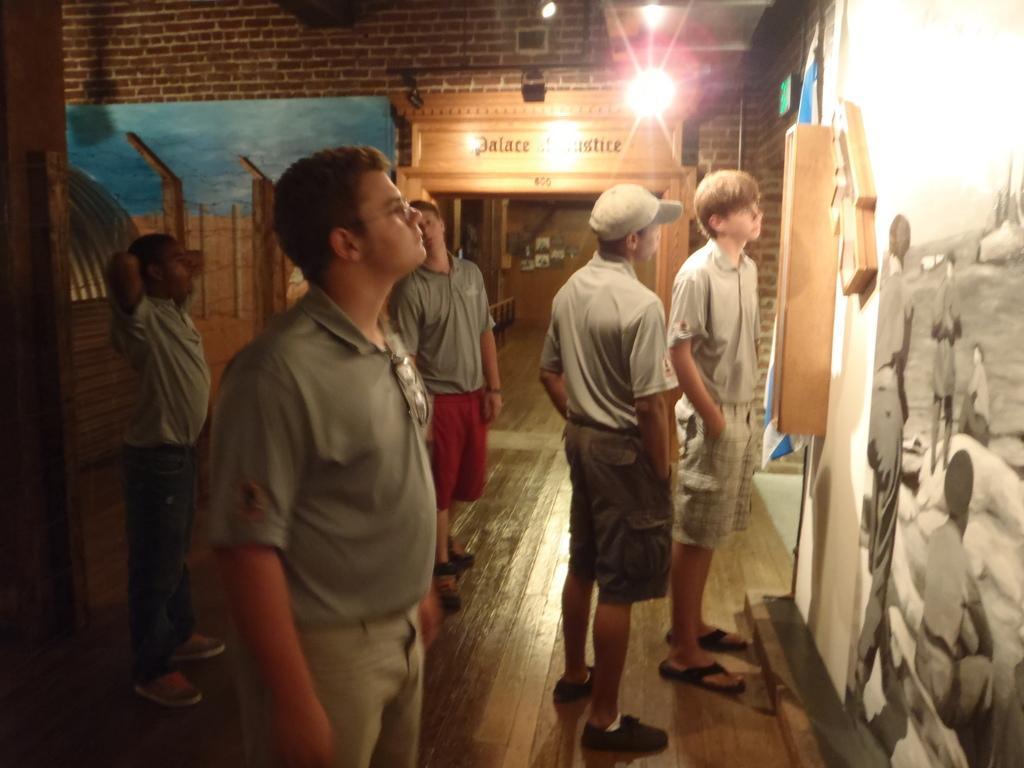Can you describe this image briefly? In the image there are few men in grey t-shirt and shorts standing on the wooden floor in front of the wall with paintings and arts on it, in the back there is bulb on the brick wall. 